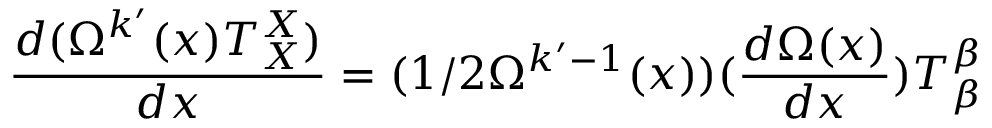<formula> <loc_0><loc_0><loc_500><loc_500>\frac { d ( \Omega ^ { k ^ { \prime } } ( x ) T _ { X } ^ { X } ) } { d x } = ( 1 / 2 \Omega ^ { k ^ { \prime } - 1 } ( x ) ) ( \frac { d \Omega ( x ) } { d x } ) T _ { \beta } ^ { \beta }</formula> 